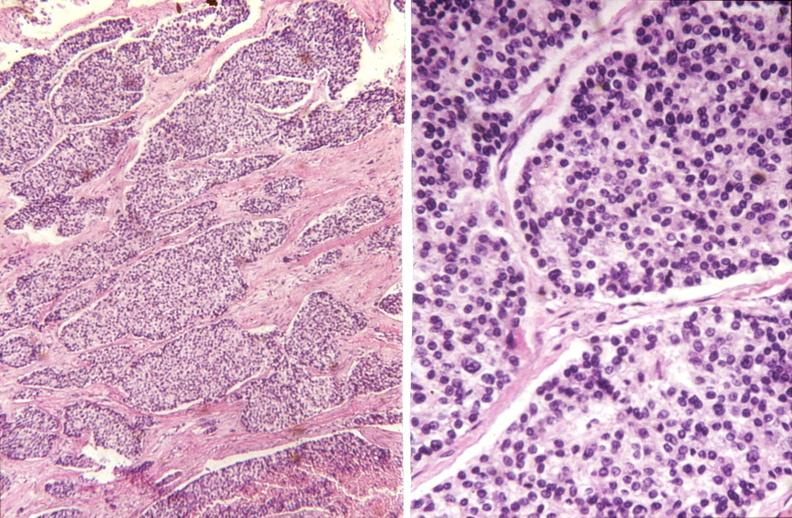does thyroid show parathyroid, carcinoma?
Answer the question using a single word or phrase. No 